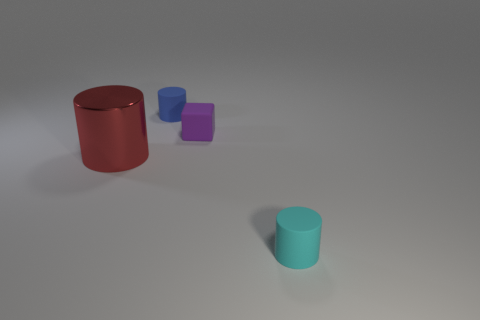There is a red cylinder; is its size the same as the matte cylinder that is in front of the red cylinder?
Your answer should be compact. No. What number of things are cyan objects or small cylinders that are behind the purple block?
Keep it short and to the point. 2. There is a rubber cylinder in front of the large red cylinder; is its size the same as the rubber cylinder that is left of the tiny cyan cylinder?
Make the answer very short. Yes. Is there a large thing made of the same material as the tiny cyan cylinder?
Provide a succinct answer. No. There is a blue object; what shape is it?
Offer a very short reply. Cylinder. There is a purple thing in front of the small rubber cylinder behind the large red metal cylinder; what shape is it?
Ensure brevity in your answer.  Cube. What number of other objects are there of the same shape as the cyan thing?
Your response must be concise. 2. There is a rubber cylinder that is behind the tiny purple rubber block that is in front of the tiny blue thing; how big is it?
Ensure brevity in your answer.  Small. Is there a large brown matte sphere?
Offer a very short reply. No. There is a matte cylinder on the right side of the blue thing; what number of small purple blocks are in front of it?
Make the answer very short. 0. 